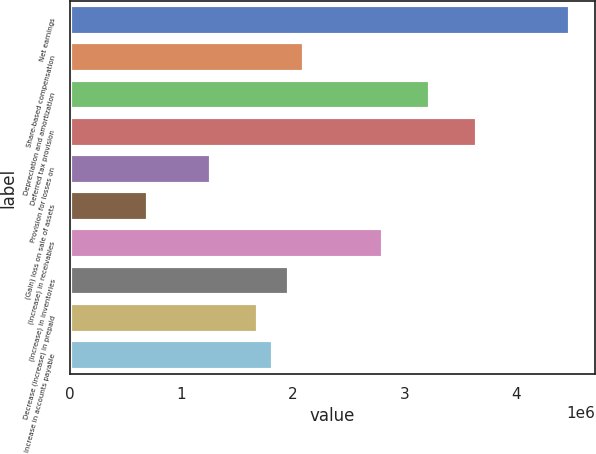Convert chart. <chart><loc_0><loc_0><loc_500><loc_500><bar_chart><fcel>Net earnings<fcel>Share-based compensation<fcel>Depreciation and amortization<fcel>Deferred tax provision<fcel>Provision for losses on<fcel>(Gain) loss on sale of assets<fcel>(Increase) in receivables<fcel>(Increase) in inventories<fcel>Decrease (increase) in prepaid<fcel>Increase in accounts payable<nl><fcel>4.48934e+06<fcel>2.10438e+06<fcel>3.22671e+06<fcel>3.64759e+06<fcel>1.26263e+06<fcel>701464<fcel>2.80584e+06<fcel>1.96409e+06<fcel>1.6835e+06<fcel>1.8238e+06<nl></chart> 